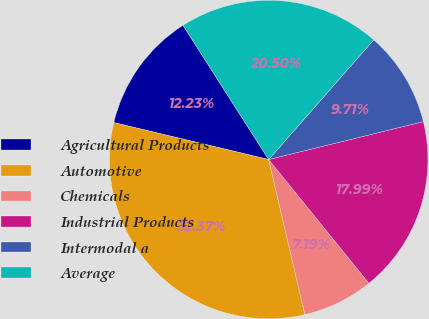Convert chart to OTSL. <chart><loc_0><loc_0><loc_500><loc_500><pie_chart><fcel>Agricultural Products<fcel>Automotive<fcel>Chemicals<fcel>Industrial Products<fcel>Intermodal a<fcel>Average<nl><fcel>12.23%<fcel>32.37%<fcel>7.19%<fcel>17.99%<fcel>9.71%<fcel>20.5%<nl></chart> 